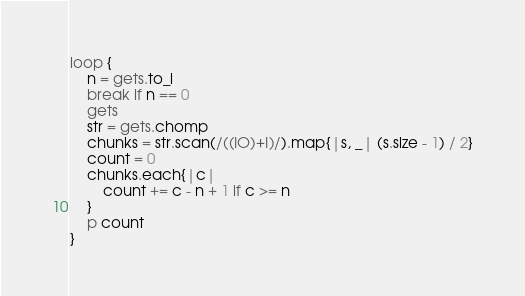Convert code to text. <code><loc_0><loc_0><loc_500><loc_500><_Ruby_>loop {
    n = gets.to_i
    break if n == 0
    gets
    str = gets.chomp
    chunks = str.scan(/((IO)+I)/).map{|s, _| (s.size - 1) / 2}
    count = 0
    chunks.each{|c|
        count += c - n + 1 if c >= n
    }
    p count
}</code> 